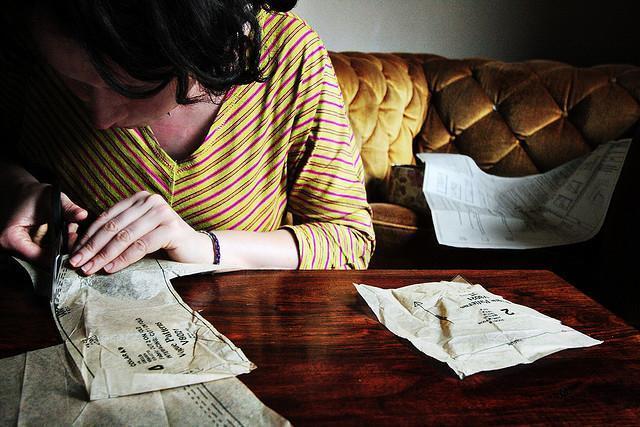Is the caption "The couch is behind the dining table." a true representation of the image?
Answer yes or no. Yes. 